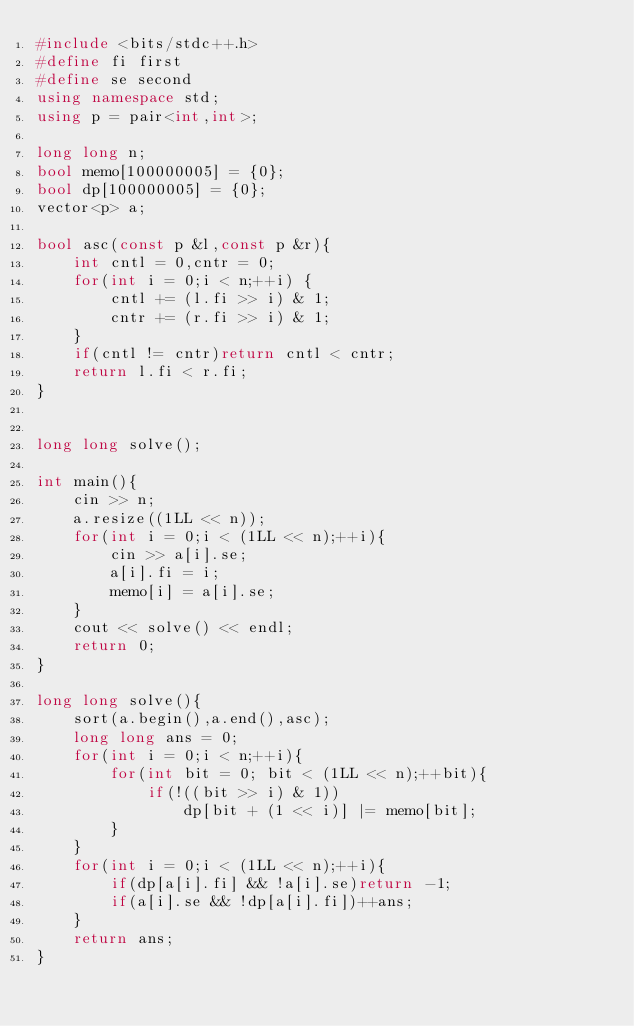<code> <loc_0><loc_0><loc_500><loc_500><_C++_>#include <bits/stdc++.h>
#define fi first
#define se second
using namespace std;
using p = pair<int,int>;

long long n;
bool memo[100000005] = {0};
bool dp[100000005] = {0};
vector<p> a;

bool asc(const p &l,const p &r){
    int cntl = 0,cntr = 0;
    for(int i = 0;i < n;++i) {
        cntl += (l.fi >> i) & 1;
        cntr += (r.fi >> i) & 1;
    }
    if(cntl != cntr)return cntl < cntr;
    return l.fi < r.fi;
}


long long solve();

int main(){
    cin >> n;
    a.resize((1LL << n));
    for(int i = 0;i < (1LL << n);++i){
        cin >> a[i].se;
        a[i].fi = i;
        memo[i] = a[i].se;
    }
    cout << solve() << endl;
    return 0;
}

long long solve(){
    sort(a.begin(),a.end(),asc);
    long long ans = 0;
    for(int i = 0;i < n;++i){
        for(int bit = 0; bit < (1LL << n);++bit){
            if(!((bit >> i) & 1))
                dp[bit + (1 << i)] |= memo[bit];
        }
    }
    for(int i = 0;i < (1LL << n);++i){
        if(dp[a[i].fi] && !a[i].se)return -1;
        if(a[i].se && !dp[a[i].fi])++ans;
    }
    return ans;
}
</code> 